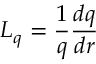Convert formula to latex. <formula><loc_0><loc_0><loc_500><loc_500>L _ { q } = \frac { 1 } { q } \frac { d q } { d r }</formula> 